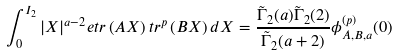<formula> <loc_0><loc_0><loc_500><loc_500>\int _ { 0 } ^ { I _ { 2 } } | X | ^ { a - 2 } e t r \left ( A X \right ) t r ^ { p } \left ( B X \right ) d X = \frac { \tilde { \Gamma } _ { 2 } ( a ) \tilde { \Gamma } _ { 2 } ( 2 ) } { \tilde { \Gamma } _ { 2 } ( a + 2 ) } \phi ^ { ( p ) } _ { A , B , a } ( 0 )</formula> 